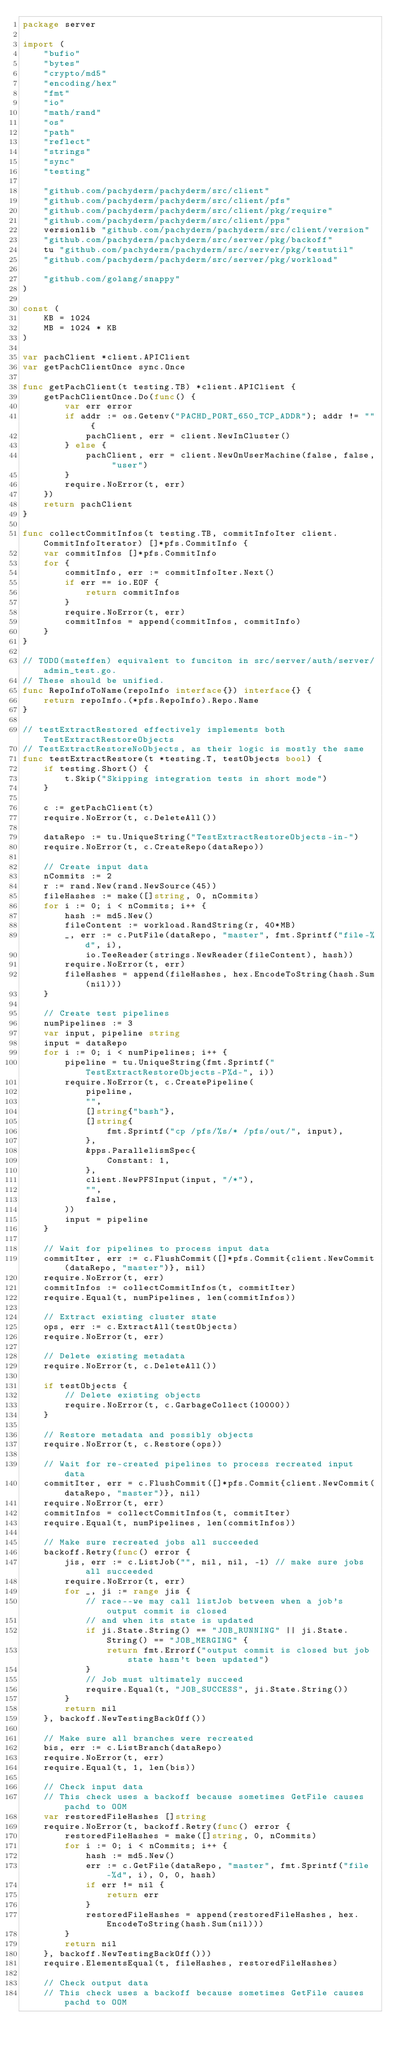Convert code to text. <code><loc_0><loc_0><loc_500><loc_500><_Go_>package server

import (
	"bufio"
	"bytes"
	"crypto/md5"
	"encoding/hex"
	"fmt"
	"io"
	"math/rand"
	"os"
	"path"
	"reflect"
	"strings"
	"sync"
	"testing"

	"github.com/pachyderm/pachyderm/src/client"
	"github.com/pachyderm/pachyderm/src/client/pfs"
	"github.com/pachyderm/pachyderm/src/client/pkg/require"
	"github.com/pachyderm/pachyderm/src/client/pps"
	versionlib "github.com/pachyderm/pachyderm/src/client/version"
	"github.com/pachyderm/pachyderm/src/server/pkg/backoff"
	tu "github.com/pachyderm/pachyderm/src/server/pkg/testutil"
	"github.com/pachyderm/pachyderm/src/server/pkg/workload"

	"github.com/golang/snappy"
)

const (
	KB = 1024
	MB = 1024 * KB
)

var pachClient *client.APIClient
var getPachClientOnce sync.Once

func getPachClient(t testing.TB) *client.APIClient {
	getPachClientOnce.Do(func() {
		var err error
		if addr := os.Getenv("PACHD_PORT_650_TCP_ADDR"); addr != "" {
			pachClient, err = client.NewInCluster()
		} else {
			pachClient, err = client.NewOnUserMachine(false, false, "user")
		}
		require.NoError(t, err)
	})
	return pachClient
}

func collectCommitInfos(t testing.TB, commitInfoIter client.CommitInfoIterator) []*pfs.CommitInfo {
	var commitInfos []*pfs.CommitInfo
	for {
		commitInfo, err := commitInfoIter.Next()
		if err == io.EOF {
			return commitInfos
		}
		require.NoError(t, err)
		commitInfos = append(commitInfos, commitInfo)
	}
}

// TODO(msteffen) equivalent to funciton in src/server/auth/server/admin_test.go.
// These should be unified.
func RepoInfoToName(repoInfo interface{}) interface{} {
	return repoInfo.(*pfs.RepoInfo).Repo.Name
}

// testExtractRestored effectively implements both TestExtractRestoreObjects
// TestExtractRestoreNoObjects, as their logic is mostly the same
func testExtractRestore(t *testing.T, testObjects bool) {
	if testing.Short() {
		t.Skip("Skipping integration tests in short mode")
	}

	c := getPachClient(t)
	require.NoError(t, c.DeleteAll())

	dataRepo := tu.UniqueString("TestExtractRestoreObjects-in-")
	require.NoError(t, c.CreateRepo(dataRepo))

	// Create input data
	nCommits := 2
	r := rand.New(rand.NewSource(45))
	fileHashes := make([]string, 0, nCommits)
	for i := 0; i < nCommits; i++ {
		hash := md5.New()
		fileContent := workload.RandString(r, 40*MB)
		_, err := c.PutFile(dataRepo, "master", fmt.Sprintf("file-%d", i),
			io.TeeReader(strings.NewReader(fileContent), hash))
		require.NoError(t, err)
		fileHashes = append(fileHashes, hex.EncodeToString(hash.Sum(nil)))
	}

	// Create test pipelines
	numPipelines := 3
	var input, pipeline string
	input = dataRepo
	for i := 0; i < numPipelines; i++ {
		pipeline = tu.UniqueString(fmt.Sprintf("TestExtractRestoreObjects-P%d-", i))
		require.NoError(t, c.CreatePipeline(
			pipeline,
			"",
			[]string{"bash"},
			[]string{
				fmt.Sprintf("cp /pfs/%s/* /pfs/out/", input),
			},
			&pps.ParallelismSpec{
				Constant: 1,
			},
			client.NewPFSInput(input, "/*"),
			"",
			false,
		))
		input = pipeline
	}

	// Wait for pipelines to process input data
	commitIter, err := c.FlushCommit([]*pfs.Commit{client.NewCommit(dataRepo, "master")}, nil)
	require.NoError(t, err)
	commitInfos := collectCommitInfos(t, commitIter)
	require.Equal(t, numPipelines, len(commitInfos))

	// Extract existing cluster state
	ops, err := c.ExtractAll(testObjects)
	require.NoError(t, err)

	// Delete existing metadata
	require.NoError(t, c.DeleteAll())

	if testObjects {
		// Delete existing objects
		require.NoError(t, c.GarbageCollect(10000))
	}

	// Restore metadata and possibly objects
	require.NoError(t, c.Restore(ops))

	// Wait for re-created pipelines to process recreated input data
	commitIter, err = c.FlushCommit([]*pfs.Commit{client.NewCommit(dataRepo, "master")}, nil)
	require.NoError(t, err)
	commitInfos = collectCommitInfos(t, commitIter)
	require.Equal(t, numPipelines, len(commitInfos))

	// Make sure recreated jobs all succeeded
	backoff.Retry(func() error {
		jis, err := c.ListJob("", nil, nil, -1) // make sure jobs all succeeded
		require.NoError(t, err)
		for _, ji := range jis {
			// race--we may call listJob between when a job's output commit is closed
			// and when its state is updated
			if ji.State.String() == "JOB_RUNNING" || ji.State.String() == "JOB_MERGING" {
				return fmt.Errorf("output commit is closed but job state hasn't been updated")
			}
			// Job must ultimately succeed
			require.Equal(t, "JOB_SUCCESS", ji.State.String())
		}
		return nil
	}, backoff.NewTestingBackOff())

	// Make sure all branches were recreated
	bis, err := c.ListBranch(dataRepo)
	require.NoError(t, err)
	require.Equal(t, 1, len(bis))

	// Check input data
	// This check uses a backoff because sometimes GetFile causes pachd to OOM
	var restoredFileHashes []string
	require.NoError(t, backoff.Retry(func() error {
		restoredFileHashes = make([]string, 0, nCommits)
		for i := 0; i < nCommits; i++ {
			hash := md5.New()
			err := c.GetFile(dataRepo, "master", fmt.Sprintf("file-%d", i), 0, 0, hash)
			if err != nil {
				return err
			}
			restoredFileHashes = append(restoredFileHashes, hex.EncodeToString(hash.Sum(nil)))
		}
		return nil
	}, backoff.NewTestingBackOff()))
	require.ElementsEqual(t, fileHashes, restoredFileHashes)

	// Check output data
	// This check uses a backoff because sometimes GetFile causes pachd to OOM</code> 